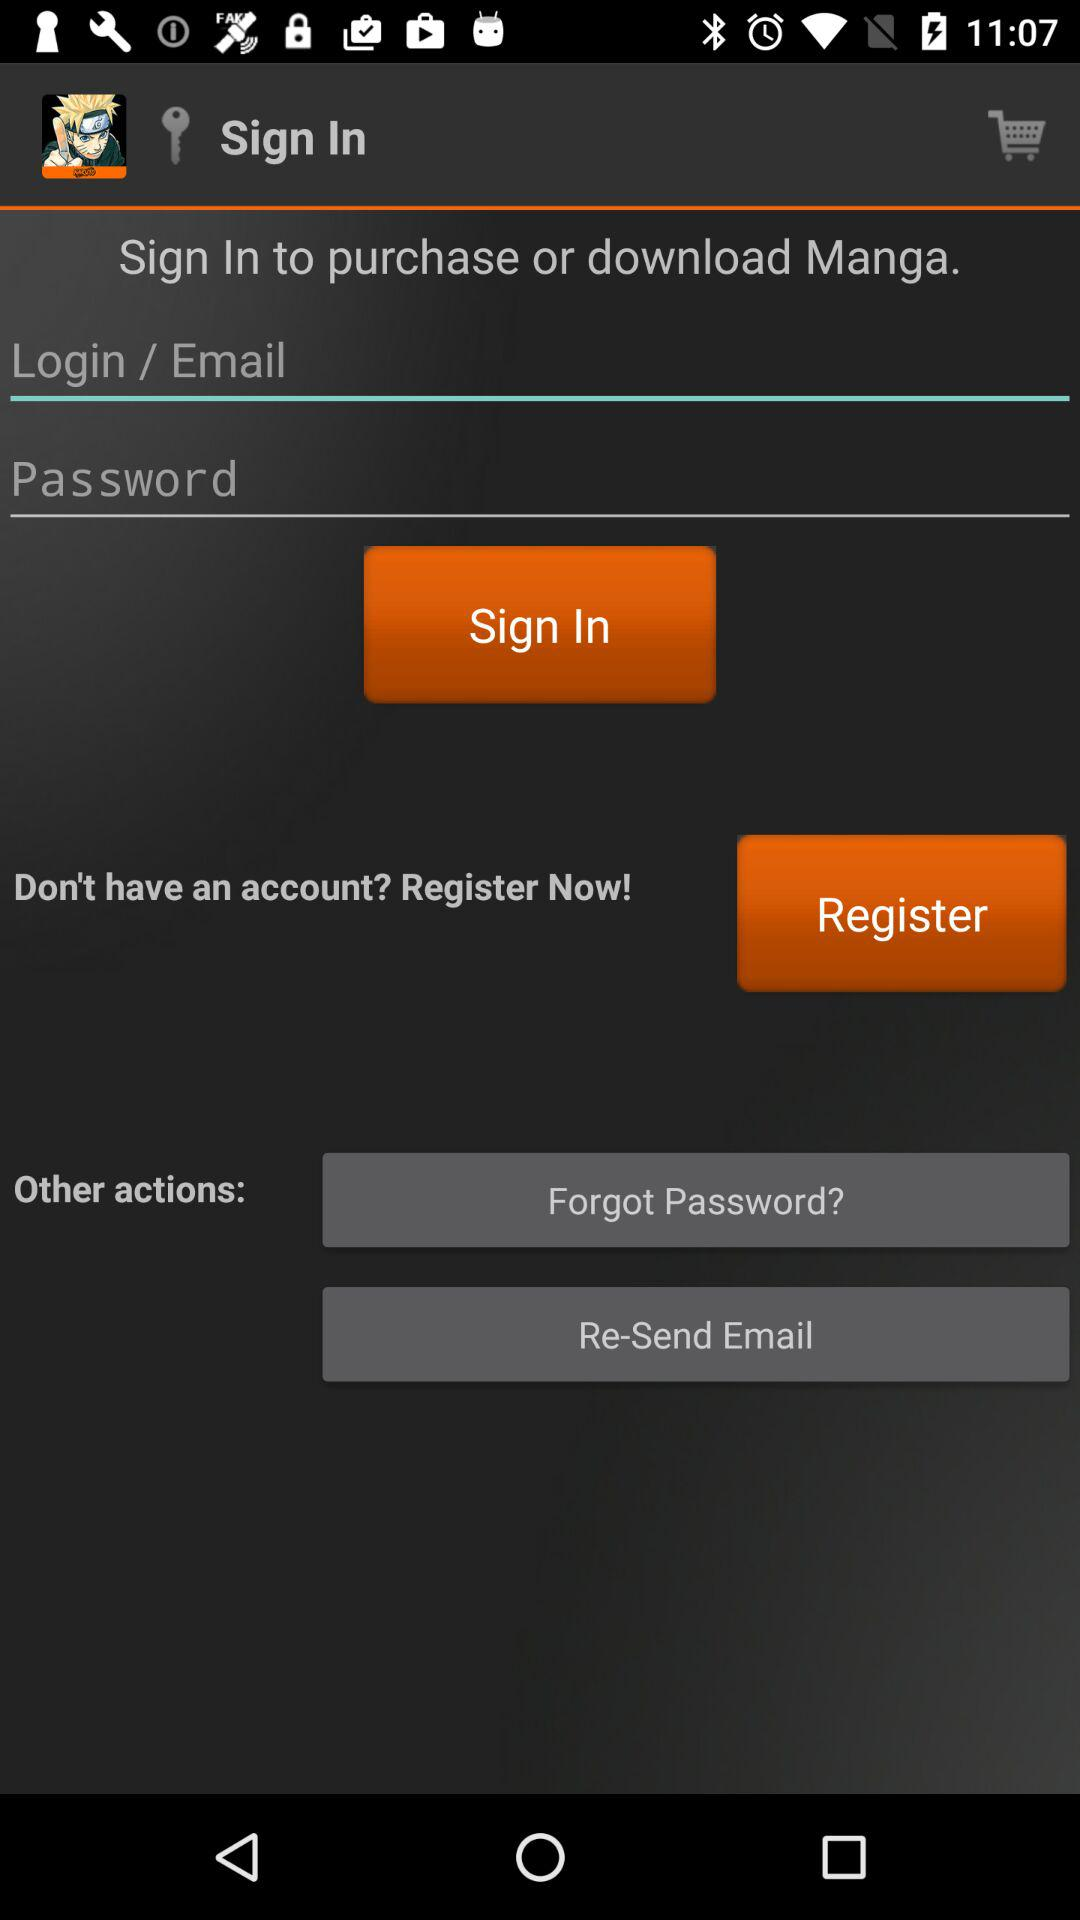What are the requirements to sign in? The requirements to sign in are login/email and password. 